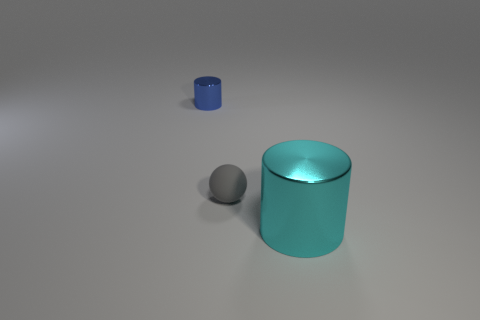What number of things are shiny cylinders behind the small ball or large cyan cylinders?
Offer a terse response. 2. There is a big cyan thing that is made of the same material as the tiny blue thing; what is its shape?
Your response must be concise. Cylinder. How many matte objects are the same shape as the tiny metallic object?
Give a very brief answer. 0. What is the large cyan cylinder made of?
Keep it short and to the point. Metal. There is a small cylinder; is its color the same as the metallic object to the right of the small metal cylinder?
Offer a very short reply. No. How many balls are either metallic things or small gray objects?
Offer a terse response. 1. There is a metal thing that is behind the rubber object; what color is it?
Give a very brief answer. Blue. How many blue matte blocks have the same size as the rubber object?
Your response must be concise. 0. There is a thing in front of the tiny gray matte sphere; is it the same shape as the tiny object that is right of the small blue metal thing?
Provide a short and direct response. No. The cylinder that is behind the cylinder that is to the right of the gray object that is in front of the tiny cylinder is made of what material?
Offer a terse response. Metal. 